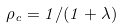Convert formula to latex. <formula><loc_0><loc_0><loc_500><loc_500>\rho _ { c } = 1 / ( 1 + \lambda )</formula> 